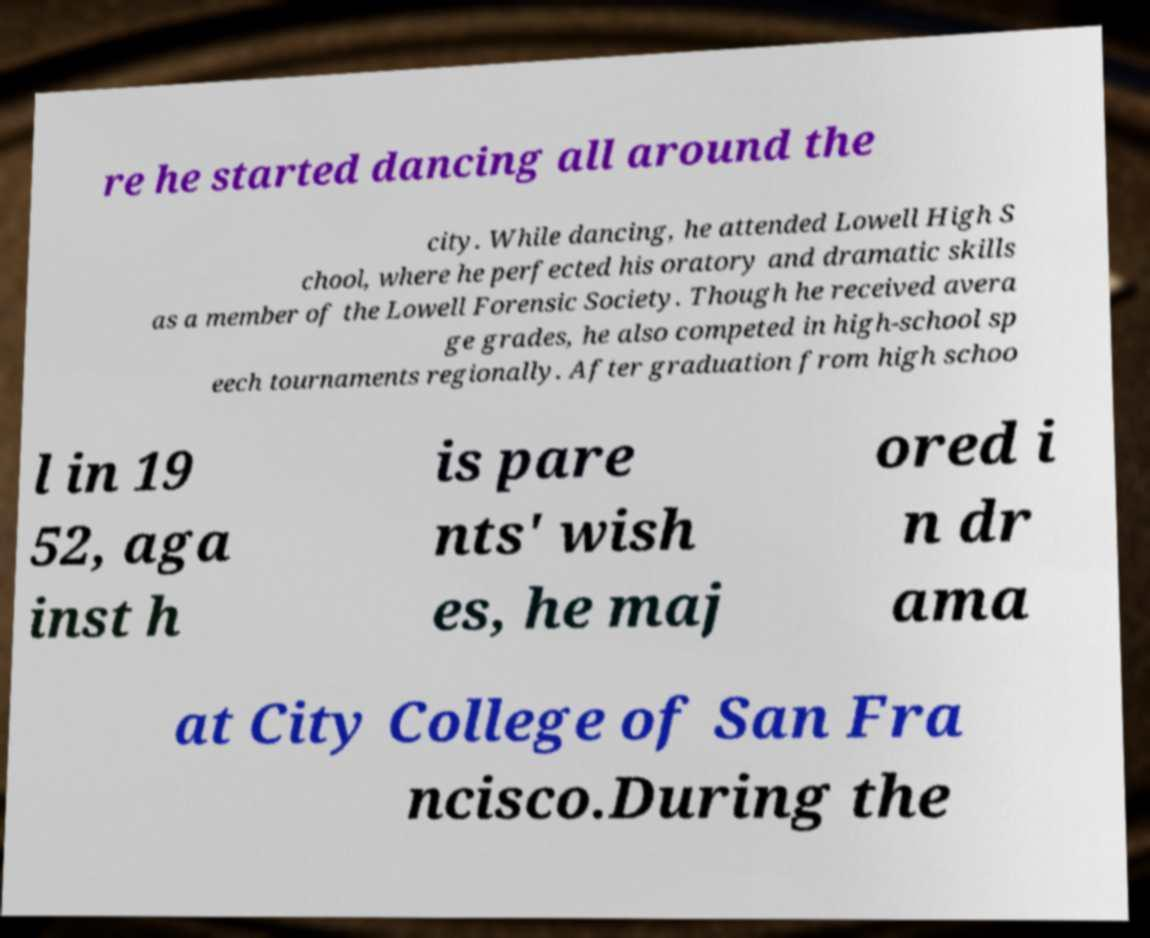Please identify and transcribe the text found in this image. re he started dancing all around the city. While dancing, he attended Lowell High S chool, where he perfected his oratory and dramatic skills as a member of the Lowell Forensic Society. Though he received avera ge grades, he also competed in high-school sp eech tournaments regionally. After graduation from high schoo l in 19 52, aga inst h is pare nts' wish es, he maj ored i n dr ama at City College of San Fra ncisco.During the 